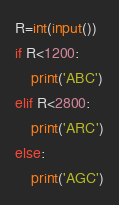Convert code to text. <code><loc_0><loc_0><loc_500><loc_500><_Python_>R=int(input())
if R<1200:
    print('ABC')
elif R<2800:
    print('ARC')
else:
    print('AGC')</code> 